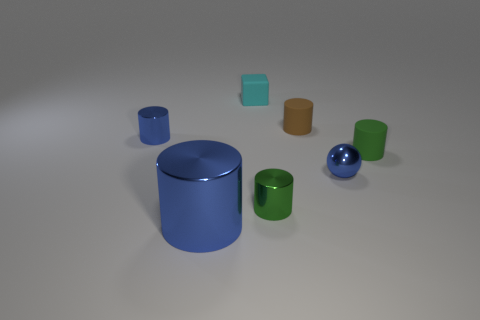Does the big shiny object have the same color as the tiny shiny ball?
Make the answer very short. Yes. There is a big metallic object that is the same color as the small ball; what is its shape?
Your response must be concise. Cylinder. There is a blue ball that is in front of the tiny green object that is behind the tiny shiny cylinder that is to the right of the cyan rubber cube; what size is it?
Your answer should be compact. Small. Does the brown matte cylinder have the same size as the green shiny thing?
Offer a very short reply. Yes. There is a tiny metallic object left of the large blue shiny thing; is its shape the same as the small green thing that is in front of the tiny ball?
Your response must be concise. Yes. Are there any small matte blocks that are in front of the tiny metallic thing left of the small rubber cube?
Offer a very short reply. No. Are any small green metal cylinders visible?
Give a very brief answer. Yes. How many cyan rubber objects are the same size as the ball?
Your response must be concise. 1. What number of cylinders are both behind the small blue sphere and left of the tiny cyan block?
Your answer should be compact. 1. Is the size of the green cylinder that is on the left side of the green matte cylinder the same as the brown cylinder?
Keep it short and to the point. Yes. 